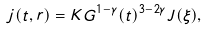<formula> <loc_0><loc_0><loc_500><loc_500>j ( t , r ) = K G ^ { 1 - \gamma } ( t ) ^ { 3 - 2 \gamma } J ( \xi ) ,</formula> 